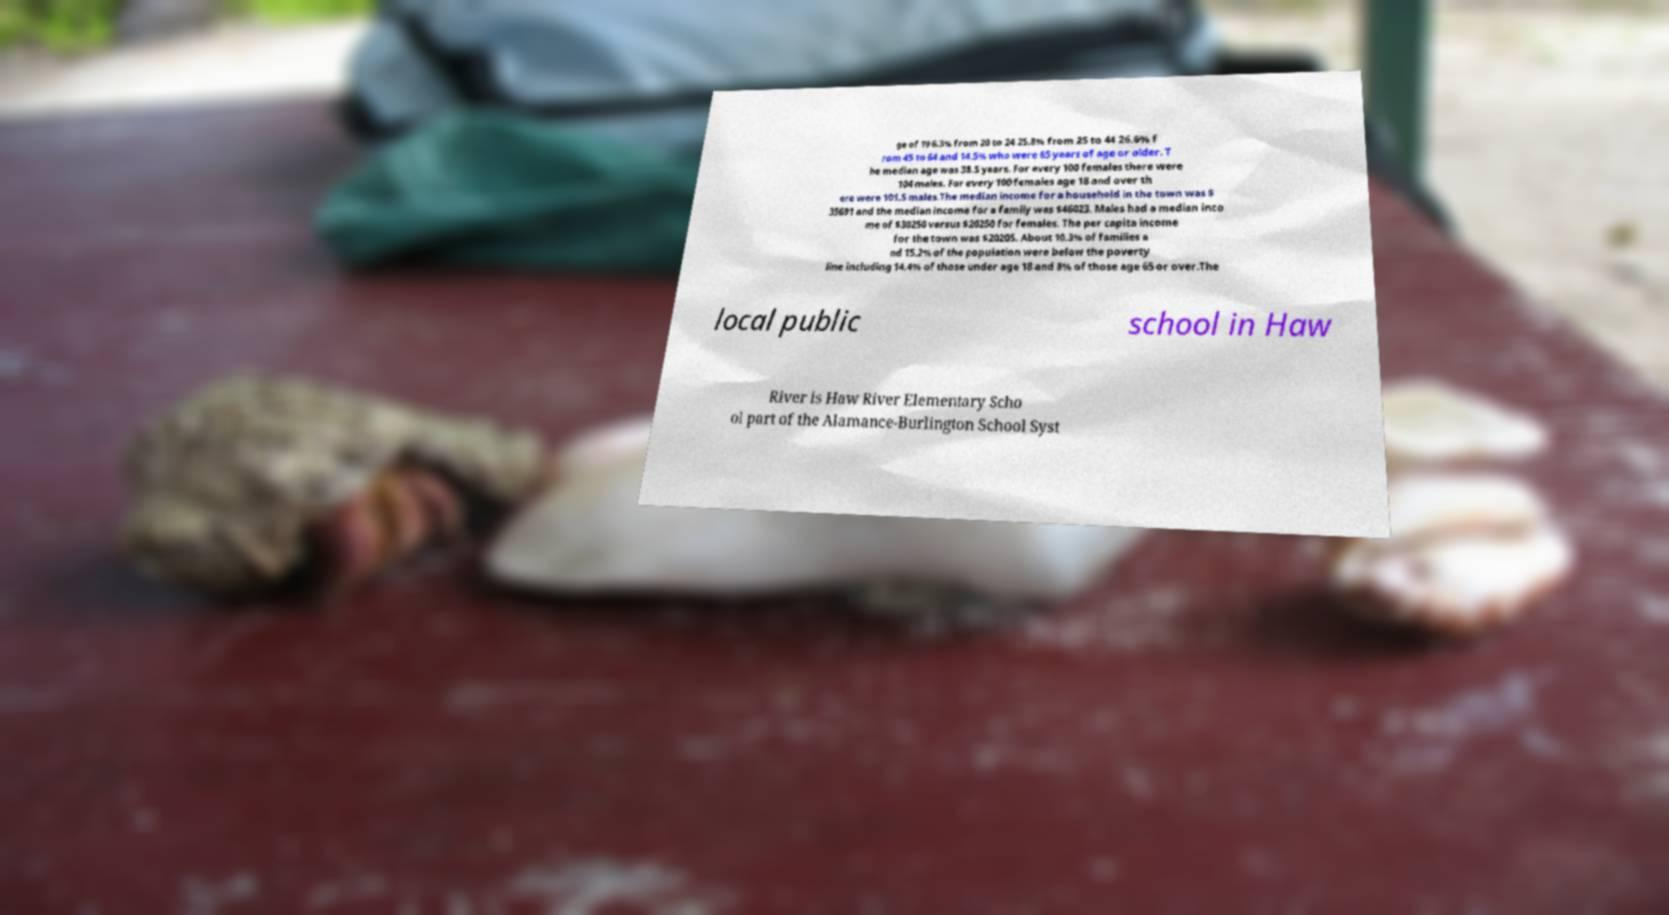Please read and relay the text visible in this image. What does it say? ge of 19 6.3% from 20 to 24 25.8% from 25 to 44 26.6% f rom 45 to 64 and 14.5% who were 65 years of age or older. T he median age was 38.5 years. For every 100 females there were 104 males. For every 100 females age 18 and over th ere were 101.5 males.The median income for a household in the town was $ 35691 and the median income for a family was $46023. Males had a median inco me of $30250 versus $20250 for females. The per capita income for the town was $20205. About 10.3% of families a nd 15.2% of the population were below the poverty line including 14.4% of those under age 18 and 8% of those age 65 or over.The local public school in Haw River is Haw River Elementary Scho ol part of the Alamance-Burlington School Syst 